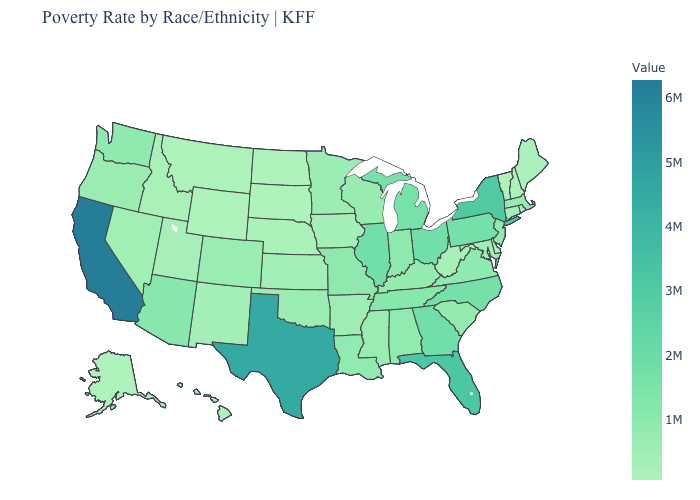Does the map have missing data?
Be succinct. No. Among the states that border Michigan , does Ohio have the highest value?
Be succinct. Yes. Which states have the highest value in the USA?
Short answer required. California. Does Nebraska have the highest value in the MidWest?
Keep it brief. No. Does Texas have a higher value than California?
Keep it brief. No. 